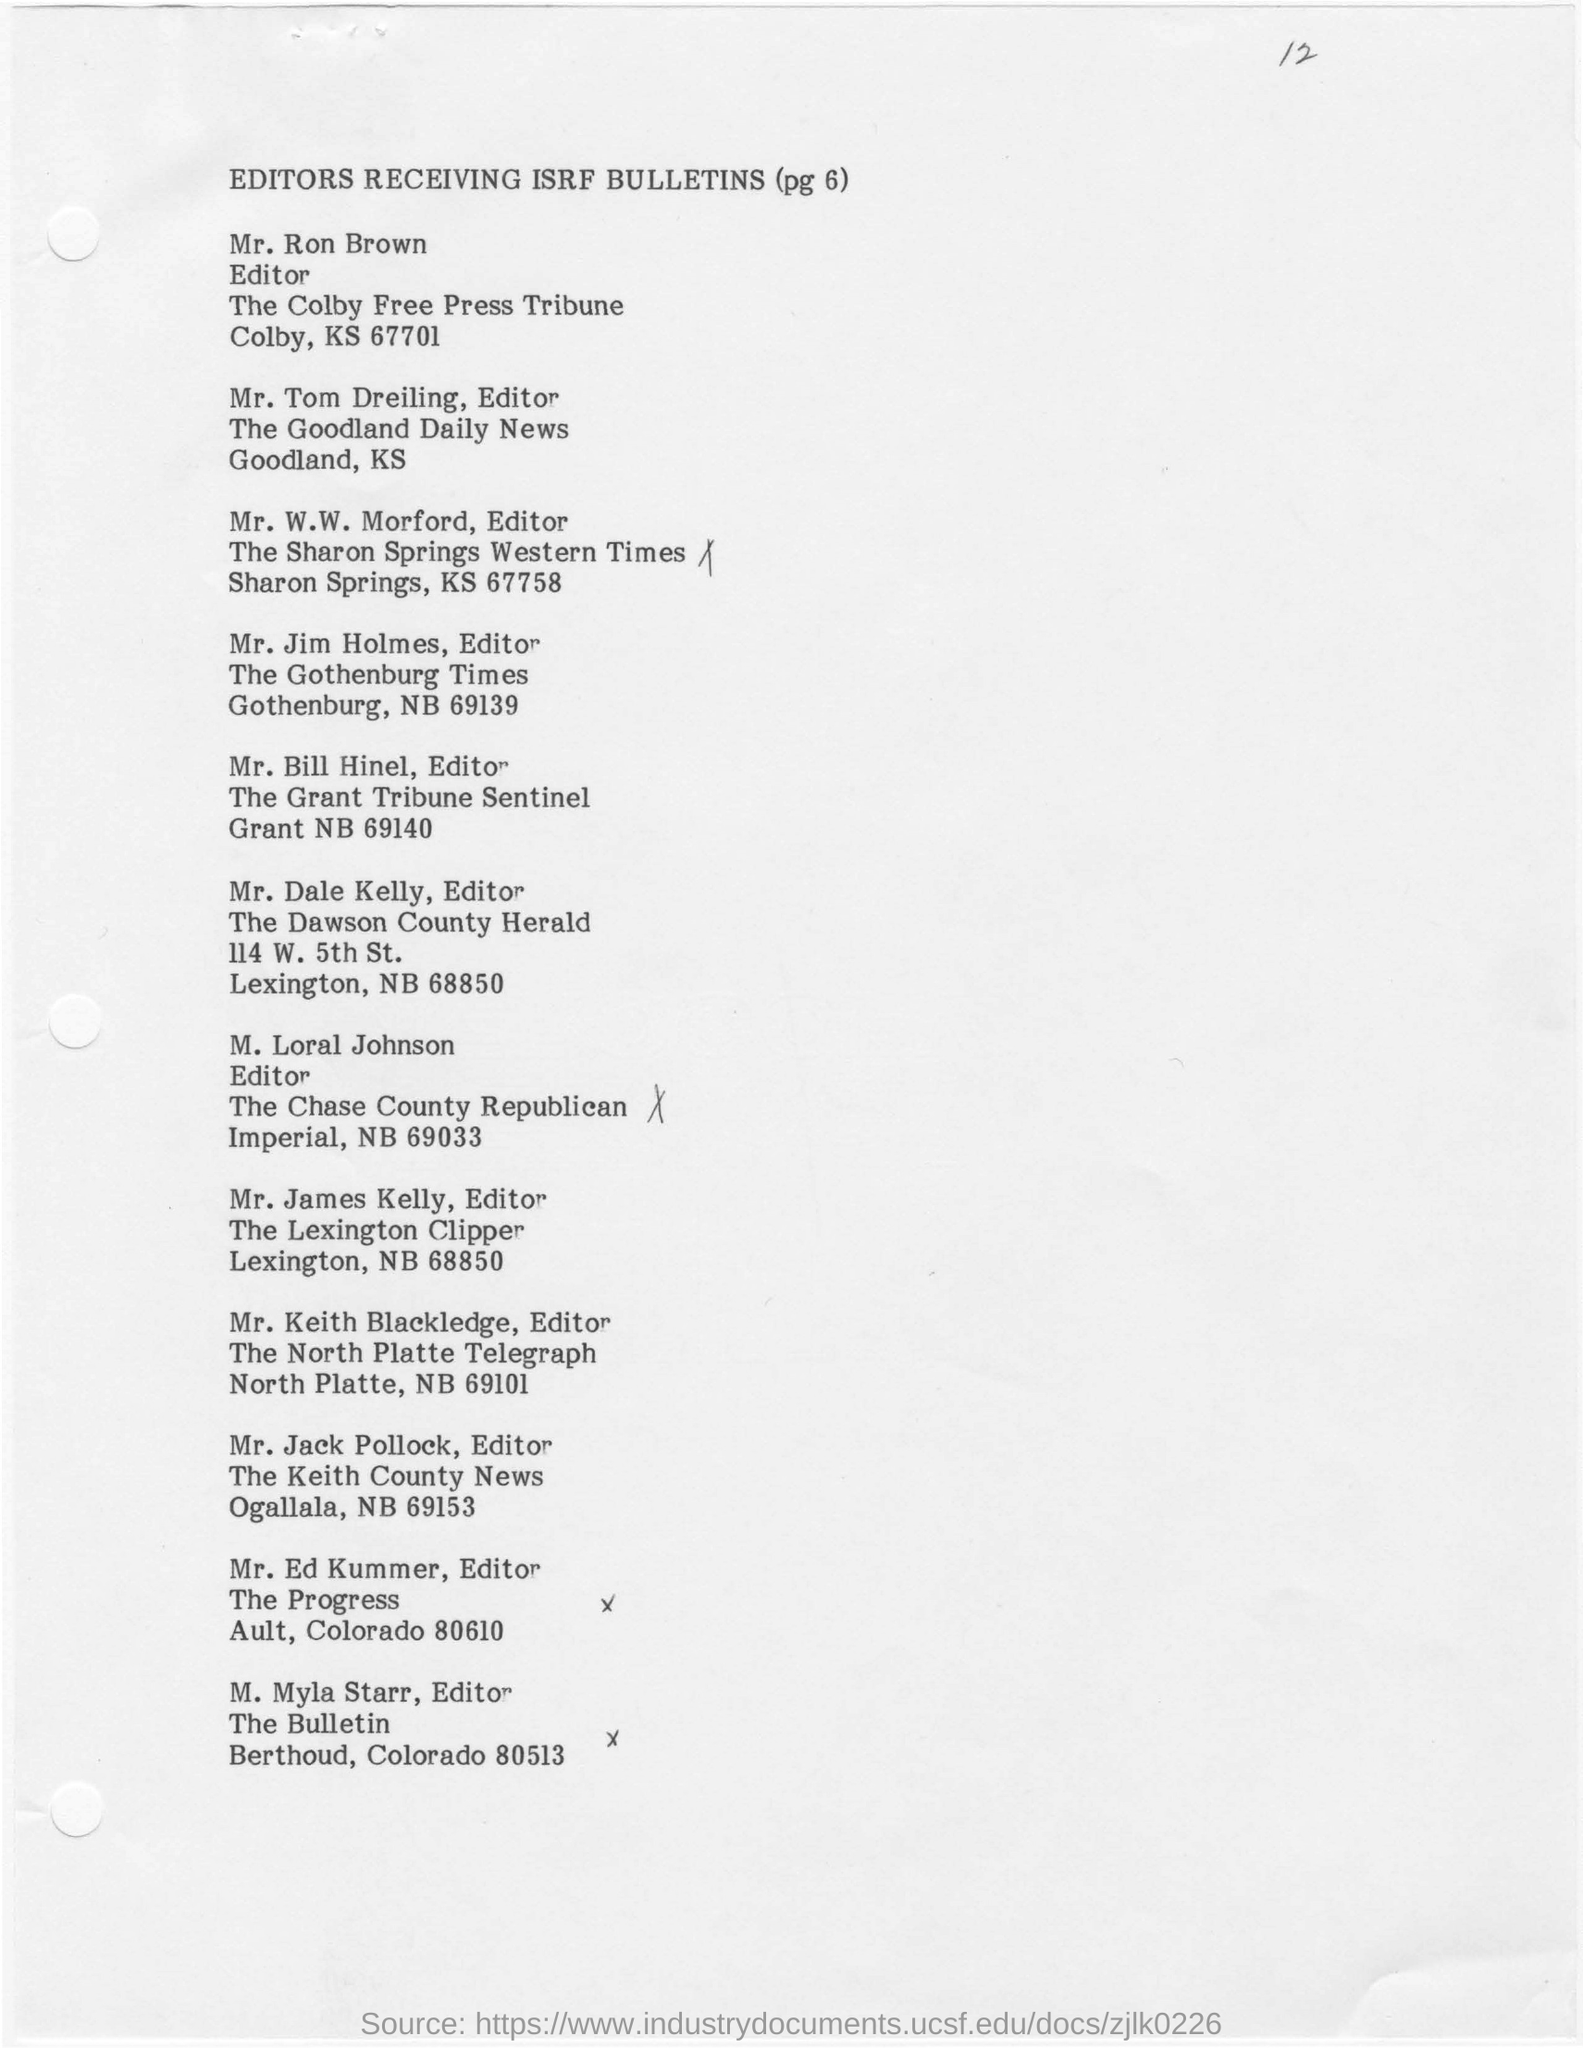Highlight a few significant elements in this photo. The editor of "The Chase Country Republican" is M. Loral Johnson. 